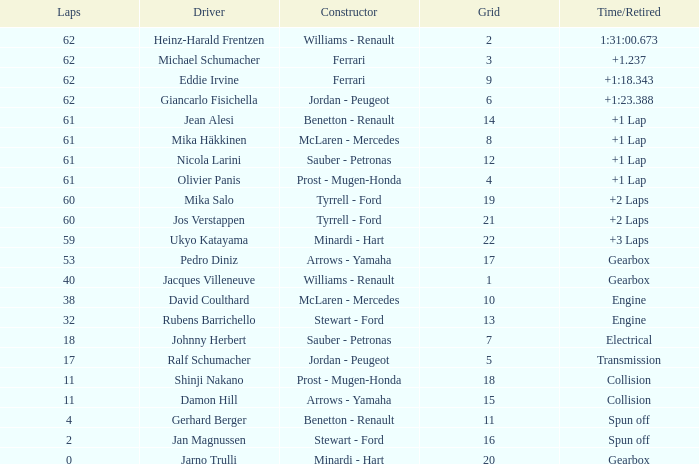What constructor has under 62 laps, a Time/Retired of gearbox, a Grid larger than 1, and pedro diniz driving? Arrows - Yamaha. 